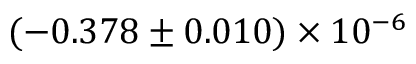Convert formula to latex. <formula><loc_0><loc_0><loc_500><loc_500>( - 0 . 3 7 8 \pm 0 . 0 1 0 ) \times 1 0 ^ { - 6 }</formula> 